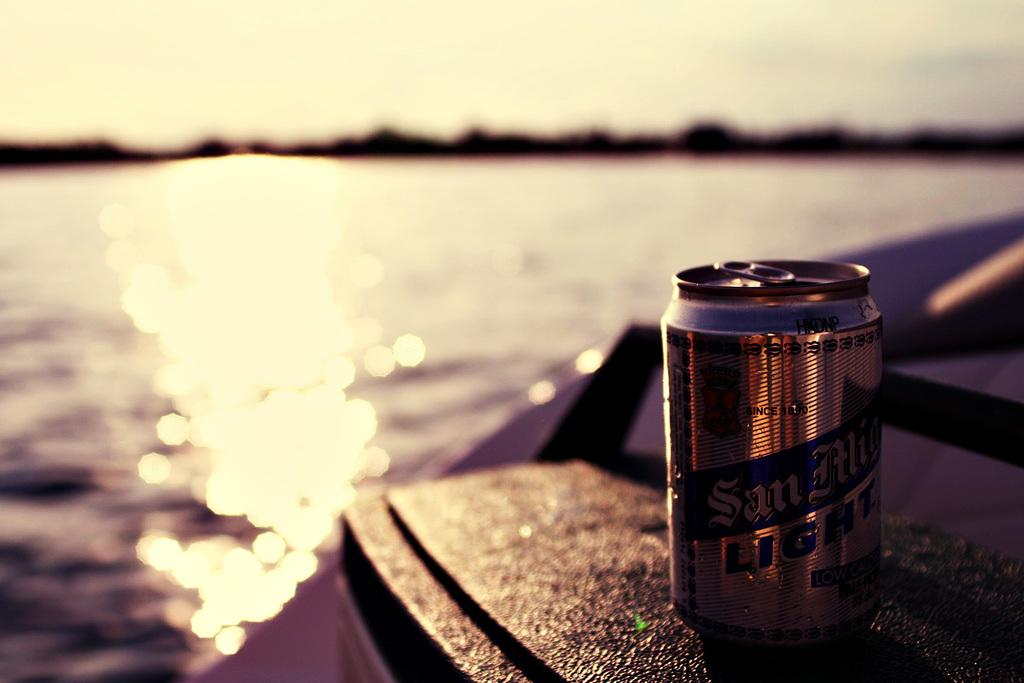<image>
Render a clear and concise summary of the photo. A lake at sunset with a silver beer can reading San Alig... Light. 